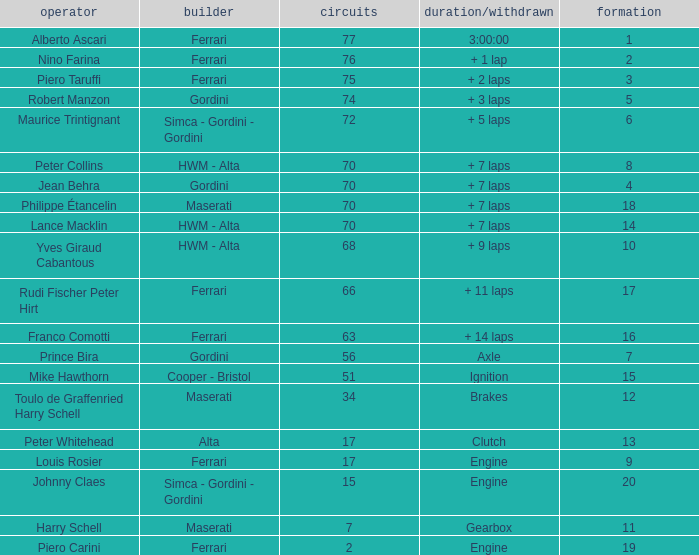What is the high grid for ferrari's with 2 laps? 19.0. Help me parse the entirety of this table. {'header': ['operator', 'builder', 'circuits', 'duration/withdrawn', 'formation'], 'rows': [['Alberto Ascari', 'Ferrari', '77', '3:00:00', '1'], ['Nino Farina', 'Ferrari', '76', '+ 1 lap', '2'], ['Piero Taruffi', 'Ferrari', '75', '+ 2 laps', '3'], ['Robert Manzon', 'Gordini', '74', '+ 3 laps', '5'], ['Maurice Trintignant', 'Simca - Gordini - Gordini', '72', '+ 5 laps', '6'], ['Peter Collins', 'HWM - Alta', '70', '+ 7 laps', '8'], ['Jean Behra', 'Gordini', '70', '+ 7 laps', '4'], ['Philippe Étancelin', 'Maserati', '70', '+ 7 laps', '18'], ['Lance Macklin', 'HWM - Alta', '70', '+ 7 laps', '14'], ['Yves Giraud Cabantous', 'HWM - Alta', '68', '+ 9 laps', '10'], ['Rudi Fischer Peter Hirt', 'Ferrari', '66', '+ 11 laps', '17'], ['Franco Comotti', 'Ferrari', '63', '+ 14 laps', '16'], ['Prince Bira', 'Gordini', '56', 'Axle', '7'], ['Mike Hawthorn', 'Cooper - Bristol', '51', 'Ignition', '15'], ['Toulo de Graffenried Harry Schell', 'Maserati', '34', 'Brakes', '12'], ['Peter Whitehead', 'Alta', '17', 'Clutch', '13'], ['Louis Rosier', 'Ferrari', '17', 'Engine', '9'], ['Johnny Claes', 'Simca - Gordini - Gordini', '15', 'Engine', '20'], ['Harry Schell', 'Maserati', '7', 'Gearbox', '11'], ['Piero Carini', 'Ferrari', '2', 'Engine', '19']]} 